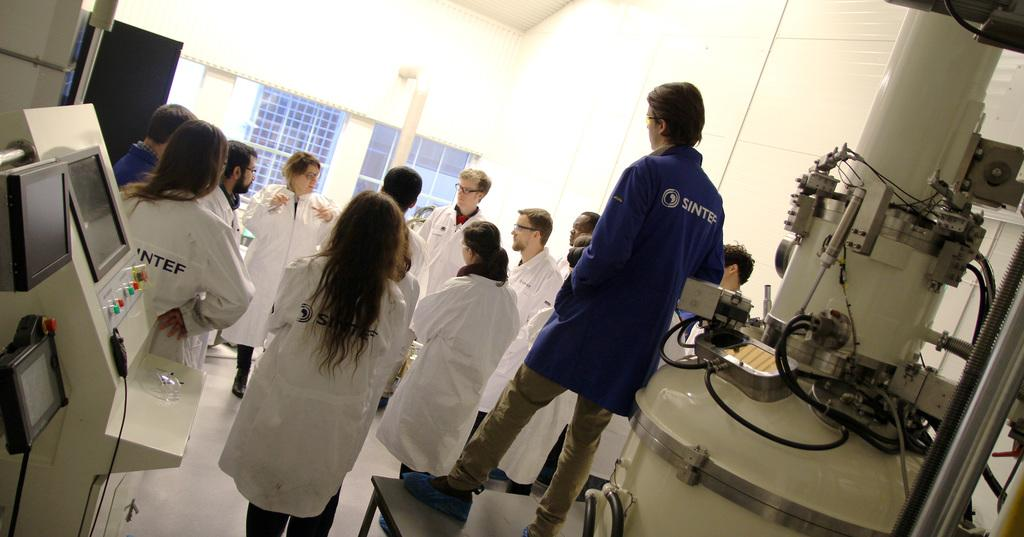What can be seen in the image involving multiple individuals? There is a group of people in the image. What are the people wearing that is noticeable? The people are wearing spectacles. How are the people positioned in the image? The people are standing. What else is present in the image besides the people? There are machines and windows in the image. What type of scent is being emitted by the bottle in the image? There is no bottle present in the image, so it is not possible to determine the scent being emitted. 